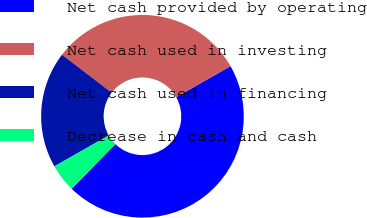Convert chart. <chart><loc_0><loc_0><loc_500><loc_500><pie_chart><fcel>Net cash provided by operating<fcel>Net cash used in investing<fcel>Net cash used in financing<fcel>Decrease in cash and cash<nl><fcel>45.54%<fcel>31.37%<fcel>18.63%<fcel>4.46%<nl></chart> 